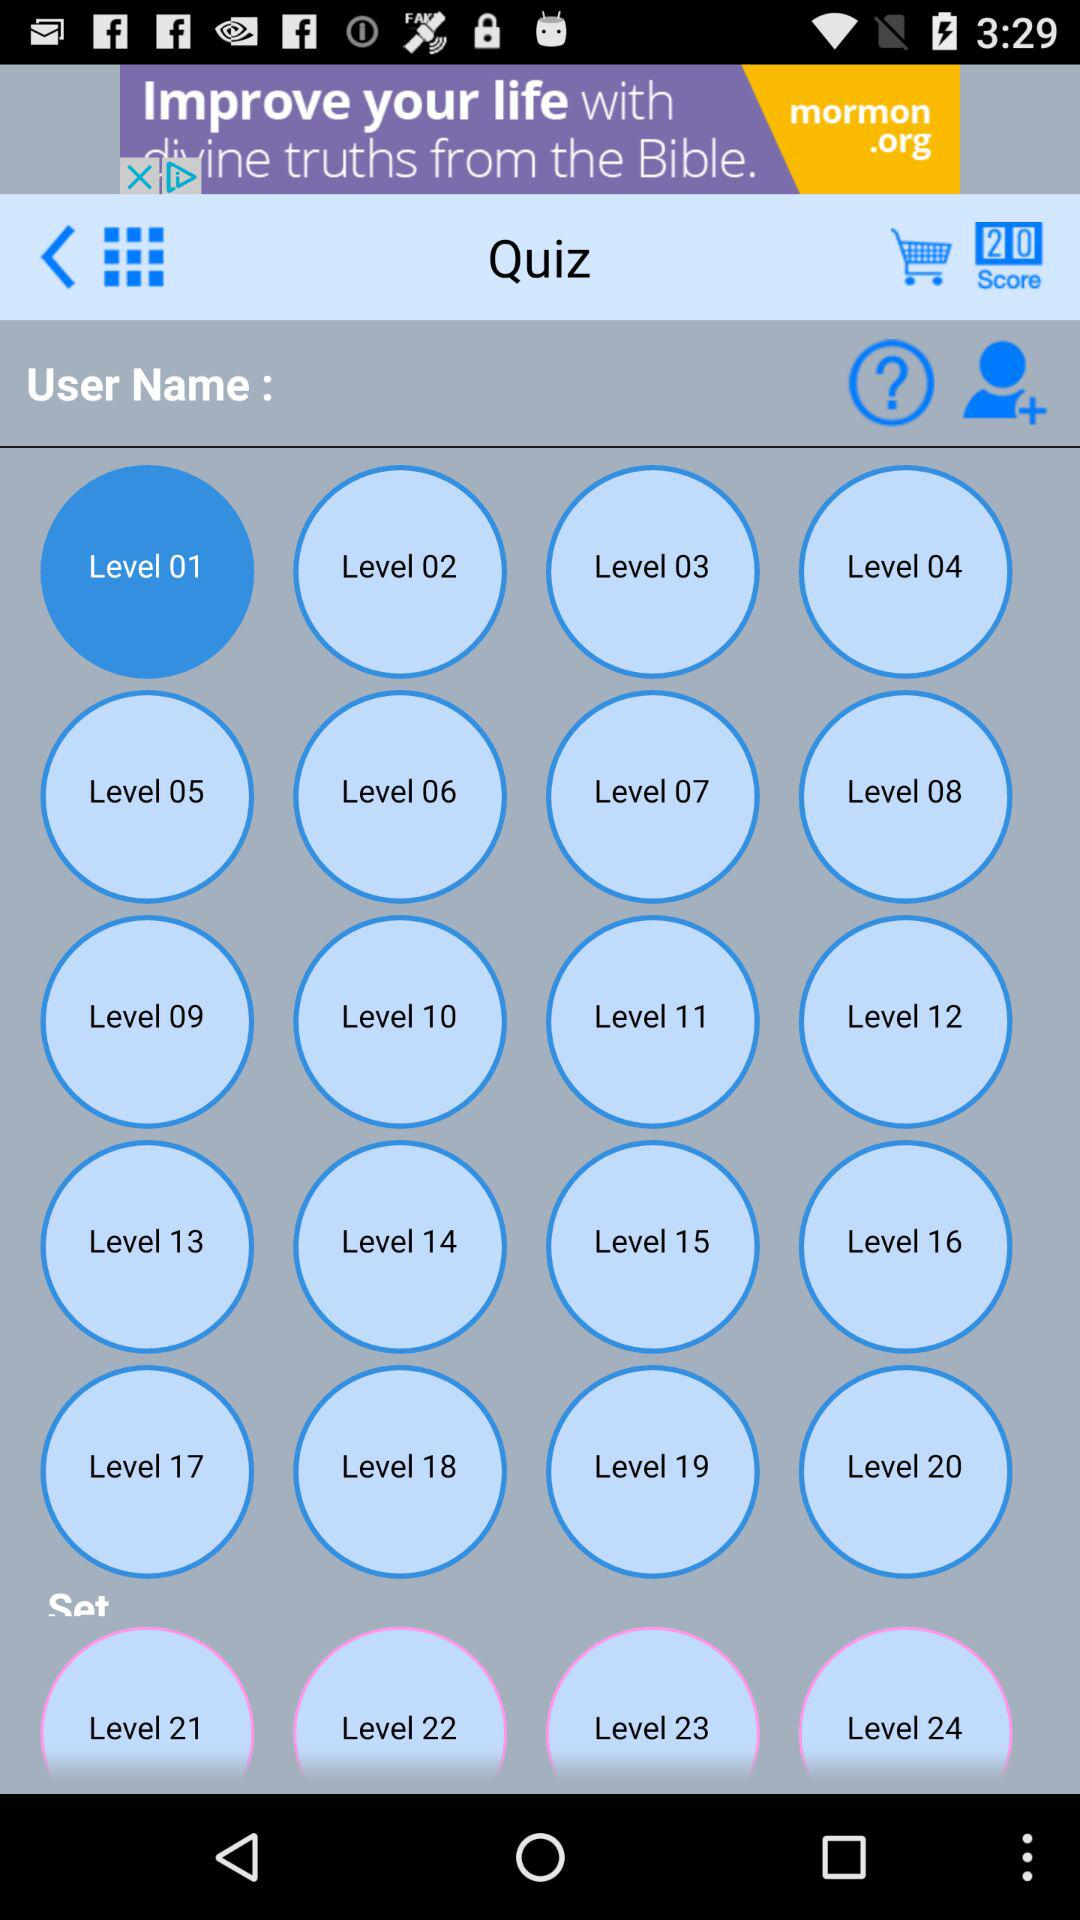What is the score? The score is 20. 